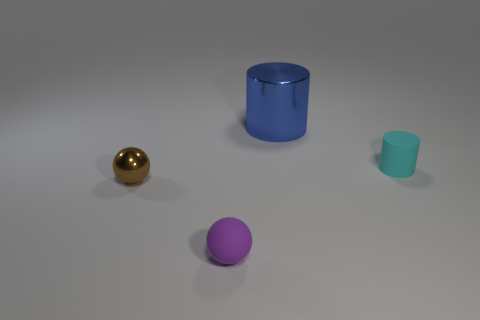Subtract all cyan cylinders. Subtract all brown spheres. How many cylinders are left? 1 Add 1 metallic spheres. How many objects exist? 5 Add 4 things. How many things exist? 8 Subtract 0 red blocks. How many objects are left? 4 Subtract all tiny brown cylinders. Subtract all purple balls. How many objects are left? 3 Add 4 balls. How many balls are left? 6 